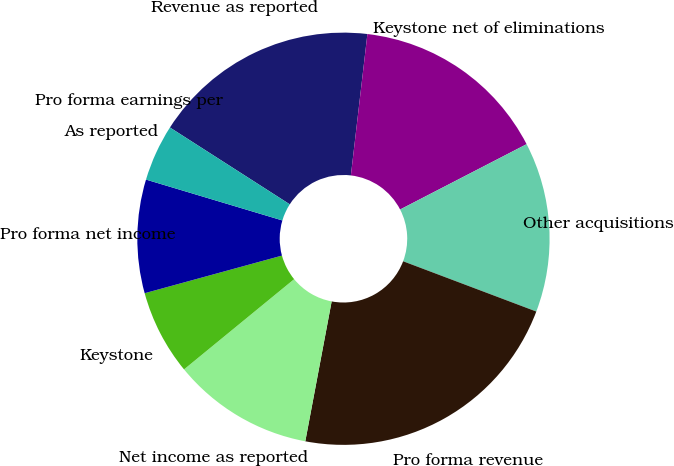Convert chart. <chart><loc_0><loc_0><loc_500><loc_500><pie_chart><fcel>Revenue as reported<fcel>Keystone net of eliminations<fcel>Other acquisitions<fcel>Pro forma revenue<fcel>Net income as reported<fcel>Keystone<fcel>Pro forma net income<fcel>As reported<fcel>Pro forma earnings per<nl><fcel>17.78%<fcel>15.56%<fcel>13.33%<fcel>22.22%<fcel>11.11%<fcel>6.67%<fcel>8.89%<fcel>4.44%<fcel>0.0%<nl></chart> 